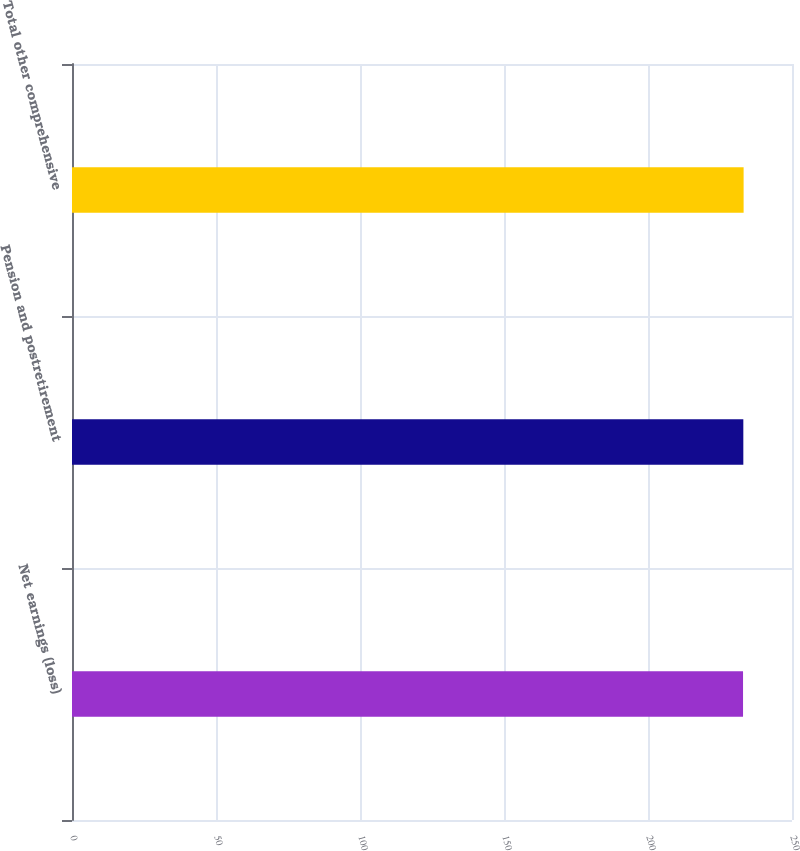Convert chart to OTSL. <chart><loc_0><loc_0><loc_500><loc_500><bar_chart><fcel>Net earnings (loss)<fcel>Pension and postretirement<fcel>Total other comprehensive<nl><fcel>233<fcel>233.1<fcel>233.2<nl></chart> 